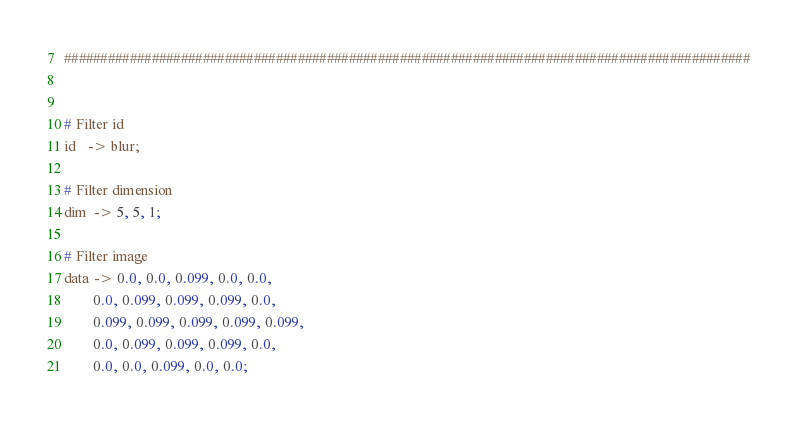Convert code to text. <code><loc_0><loc_0><loc_500><loc_500><_Forth_>##############################################################################################


# Filter id
id   -> blur;

# Filter dimension
dim  -> 5, 5, 1;

# Filter image
data -> 0.0, 0.0, 0.099, 0.0, 0.0,
        0.0, 0.099, 0.099, 0.099, 0.0,
        0.099, 0.099, 0.099, 0.099, 0.099,
        0.0, 0.099, 0.099, 0.099, 0.0,
        0.0, 0.0, 0.099, 0.0, 0.0;</code> 